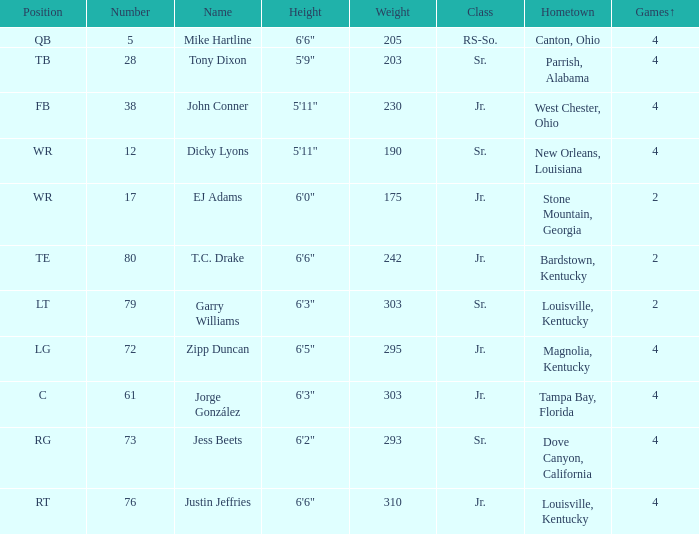Which Class has a Weight of 203? Sr. 